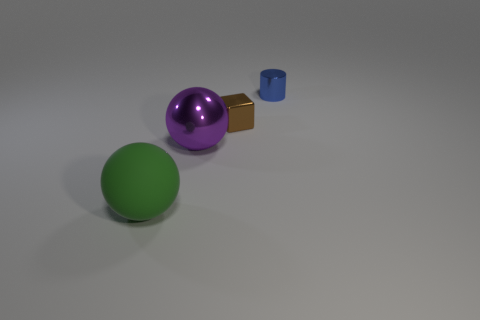There is a thing that is behind the big purple metal sphere and left of the tiny blue object; what is its size?
Offer a very short reply. Small. How many big objects are the same material as the green ball?
Ensure brevity in your answer.  0. What number of balls are either large red metal things or large green objects?
Ensure brevity in your answer.  1. There is a metallic object that is to the right of the small metallic thing that is left of the metal object right of the small brown thing; how big is it?
Give a very brief answer. Small. What is the color of the object that is in front of the tiny brown block and to the right of the matte thing?
Offer a terse response. Purple. Does the green rubber sphere have the same size as the metallic object to the right of the cube?
Ensure brevity in your answer.  No. Is there anything else that is the same shape as the tiny blue shiny thing?
Provide a succinct answer. No. The other matte object that is the same shape as the large purple object is what color?
Offer a very short reply. Green. Do the purple thing and the green thing have the same size?
Keep it short and to the point. Yes. How many other things are there of the same size as the cylinder?
Give a very brief answer. 1. 